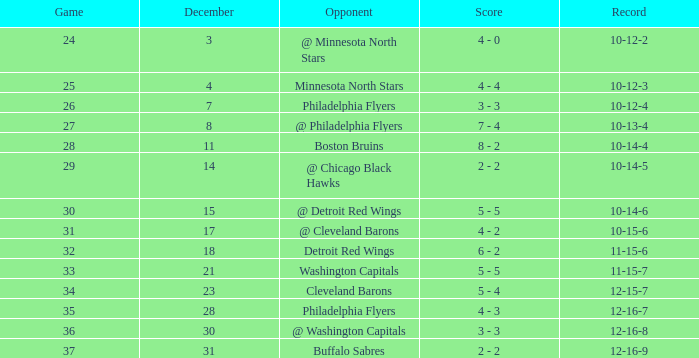What is the lowest December, when Score is "4 - 4"? 4.0. 